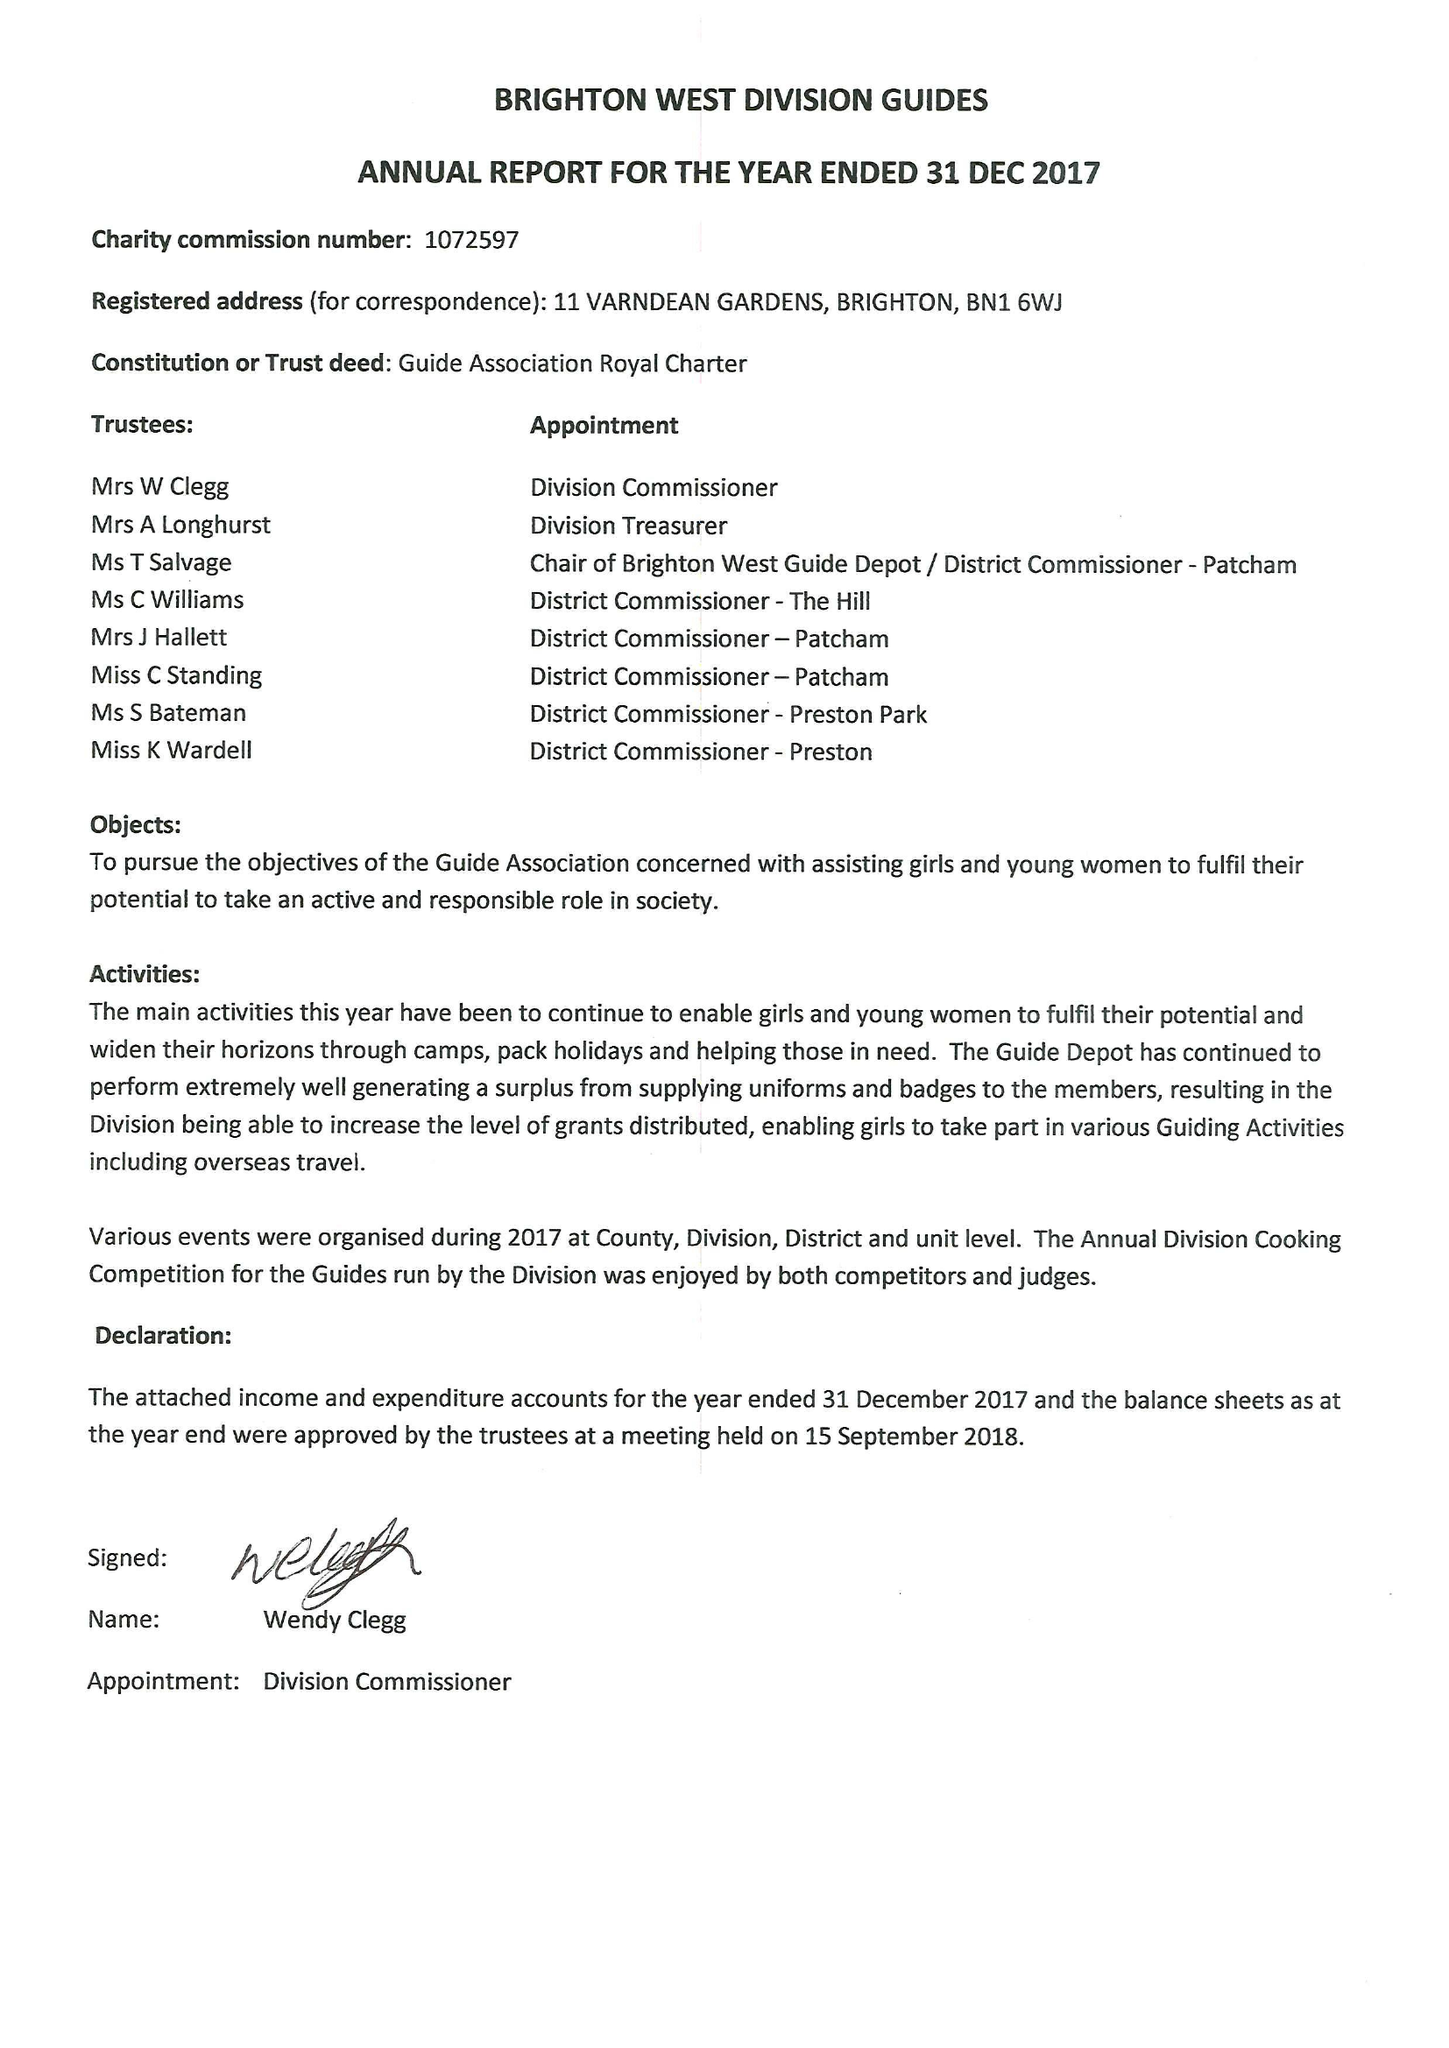What is the value for the address__post_town?
Answer the question using a single word or phrase. BRIGHTON 